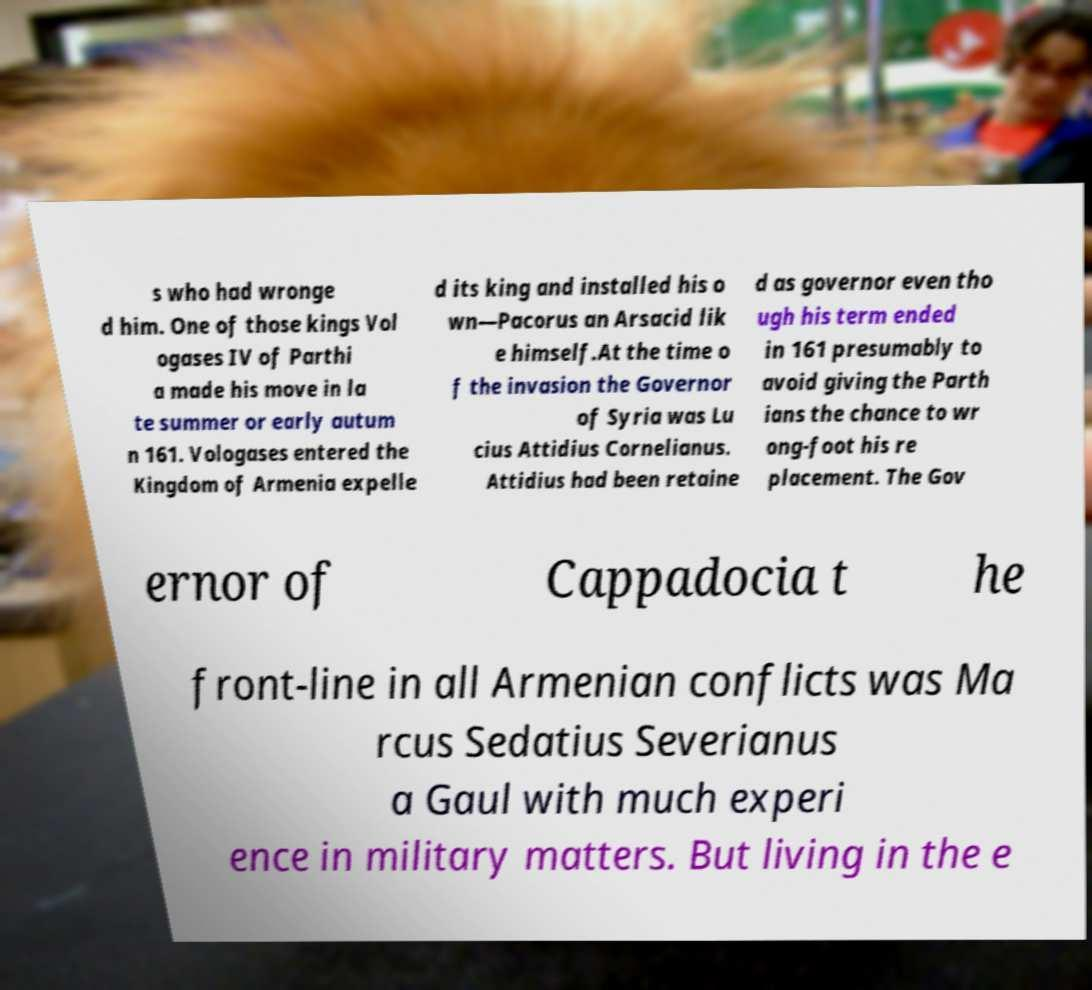What messages or text are displayed in this image? I need them in a readable, typed format. s who had wronge d him. One of those kings Vol ogases IV of Parthi a made his move in la te summer or early autum n 161. Vologases entered the Kingdom of Armenia expelle d its king and installed his o wn—Pacorus an Arsacid lik e himself.At the time o f the invasion the Governor of Syria was Lu cius Attidius Cornelianus. Attidius had been retaine d as governor even tho ugh his term ended in 161 presumably to avoid giving the Parth ians the chance to wr ong-foot his re placement. The Gov ernor of Cappadocia t he front-line in all Armenian conflicts was Ma rcus Sedatius Severianus a Gaul with much experi ence in military matters. But living in the e 